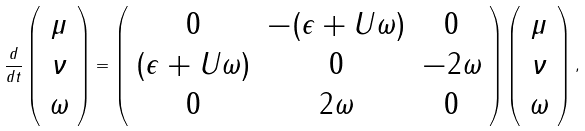Convert formula to latex. <formula><loc_0><loc_0><loc_500><loc_500>\frac { d } { d t } \left ( \begin{array} { c } \mu \\ \nu \\ \omega \end{array} \right ) = \left ( \begin{array} { c c c } 0 & - ( \epsilon + U \omega ) & 0 \\ ( \epsilon + U \omega ) & 0 & - 2 \omega \\ 0 & 2 \omega & 0 \end{array} \right ) \left ( \begin{array} { c } \mu \\ \nu \\ \omega \end{array} \right ) ,</formula> 